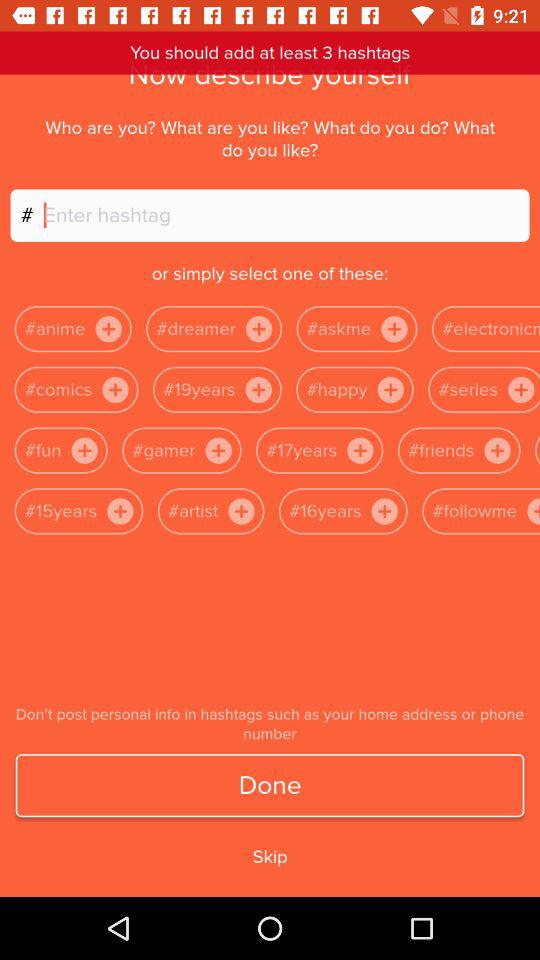What is the minimum number of hashtags I can select? The minimum number of hashtags you can select is 3. 